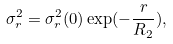Convert formula to latex. <formula><loc_0><loc_0><loc_500><loc_500>\sigma _ { r } ^ { 2 } = \sigma _ { r } ^ { 2 } ( 0 ) \exp ( - \frac { r } { R _ { 2 } } ) ,</formula> 